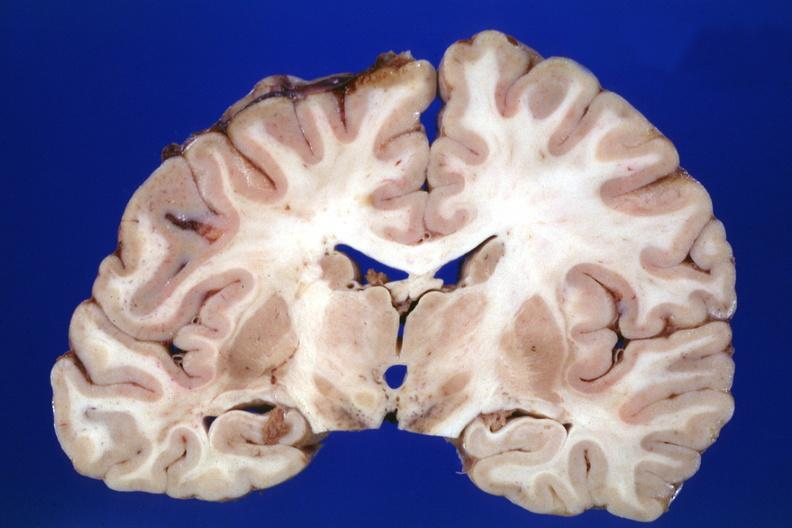s brain present?
Answer the question using a single word or phrase. Yes 